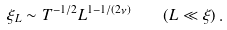<formula> <loc_0><loc_0><loc_500><loc_500>\xi _ { L } \sim T ^ { - 1 / 2 } L ^ { 1 - 1 / ( 2 \nu ) } \quad ( L \ll \xi ) \, .</formula> 